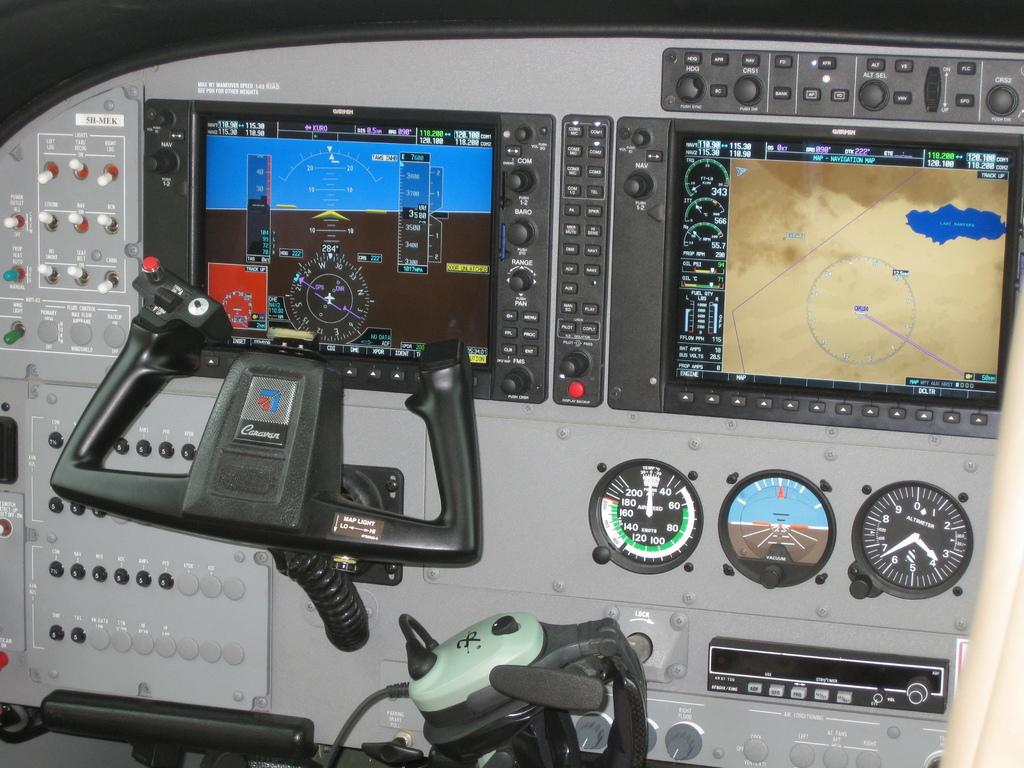<image>
Create a compact narrative representing the image presented. An aircraft instrument panel has a control wheel made by Caravan. 